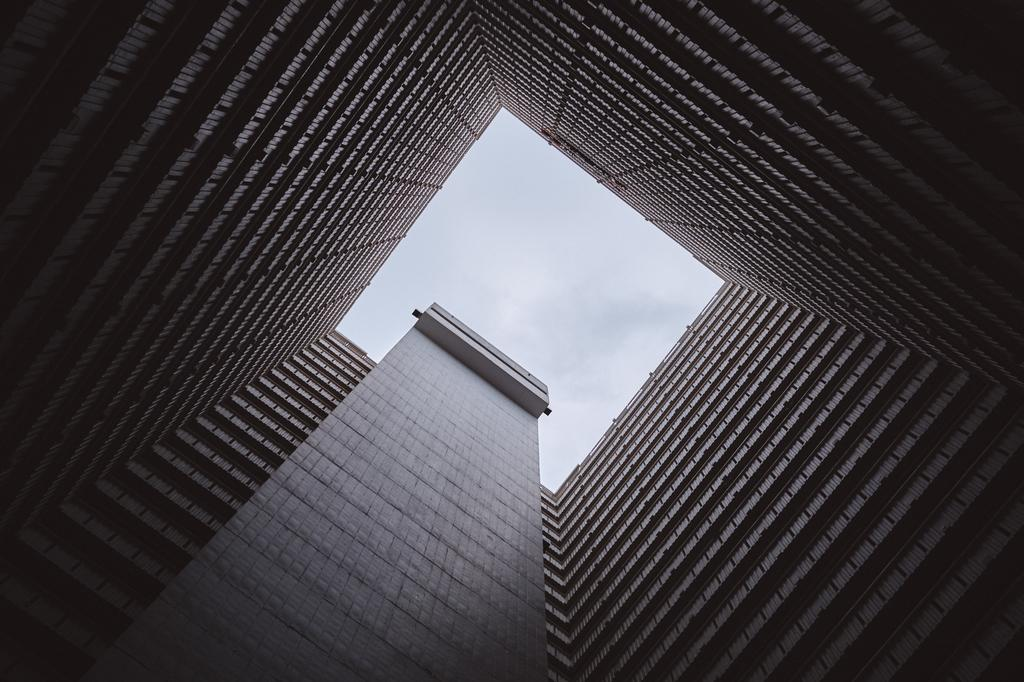What is the main subject of the image? There is a close view of a building in the image. Can you describe the background of the image? The sky is visible in the center of the image. What type of mist can be seen surrounding the flag in the image? There is no flag present in the image, so there is no mist surrounding it. 